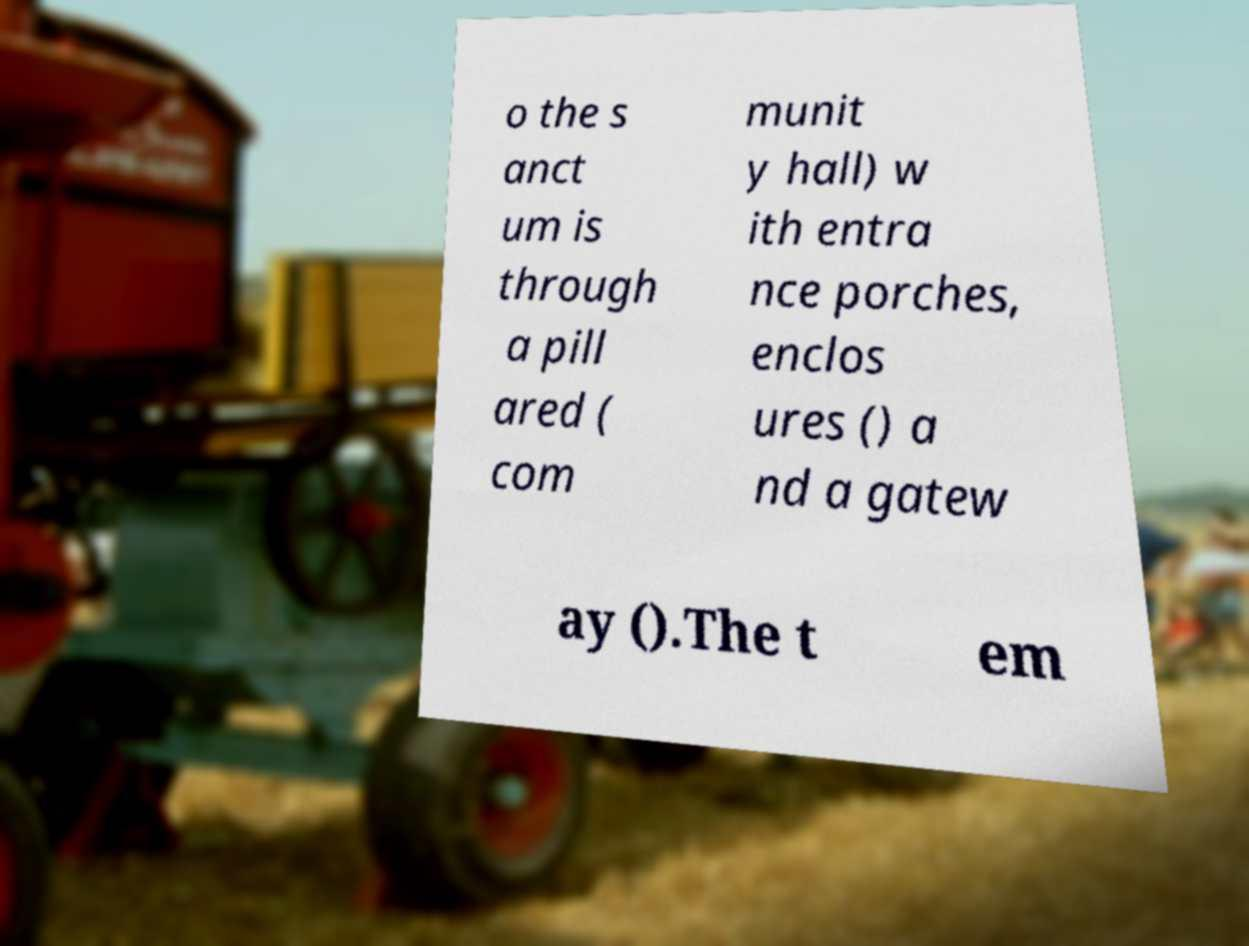Please identify and transcribe the text found in this image. o the s anct um is through a pill ared ( com munit y hall) w ith entra nce porches, enclos ures () a nd a gatew ay ().The t em 